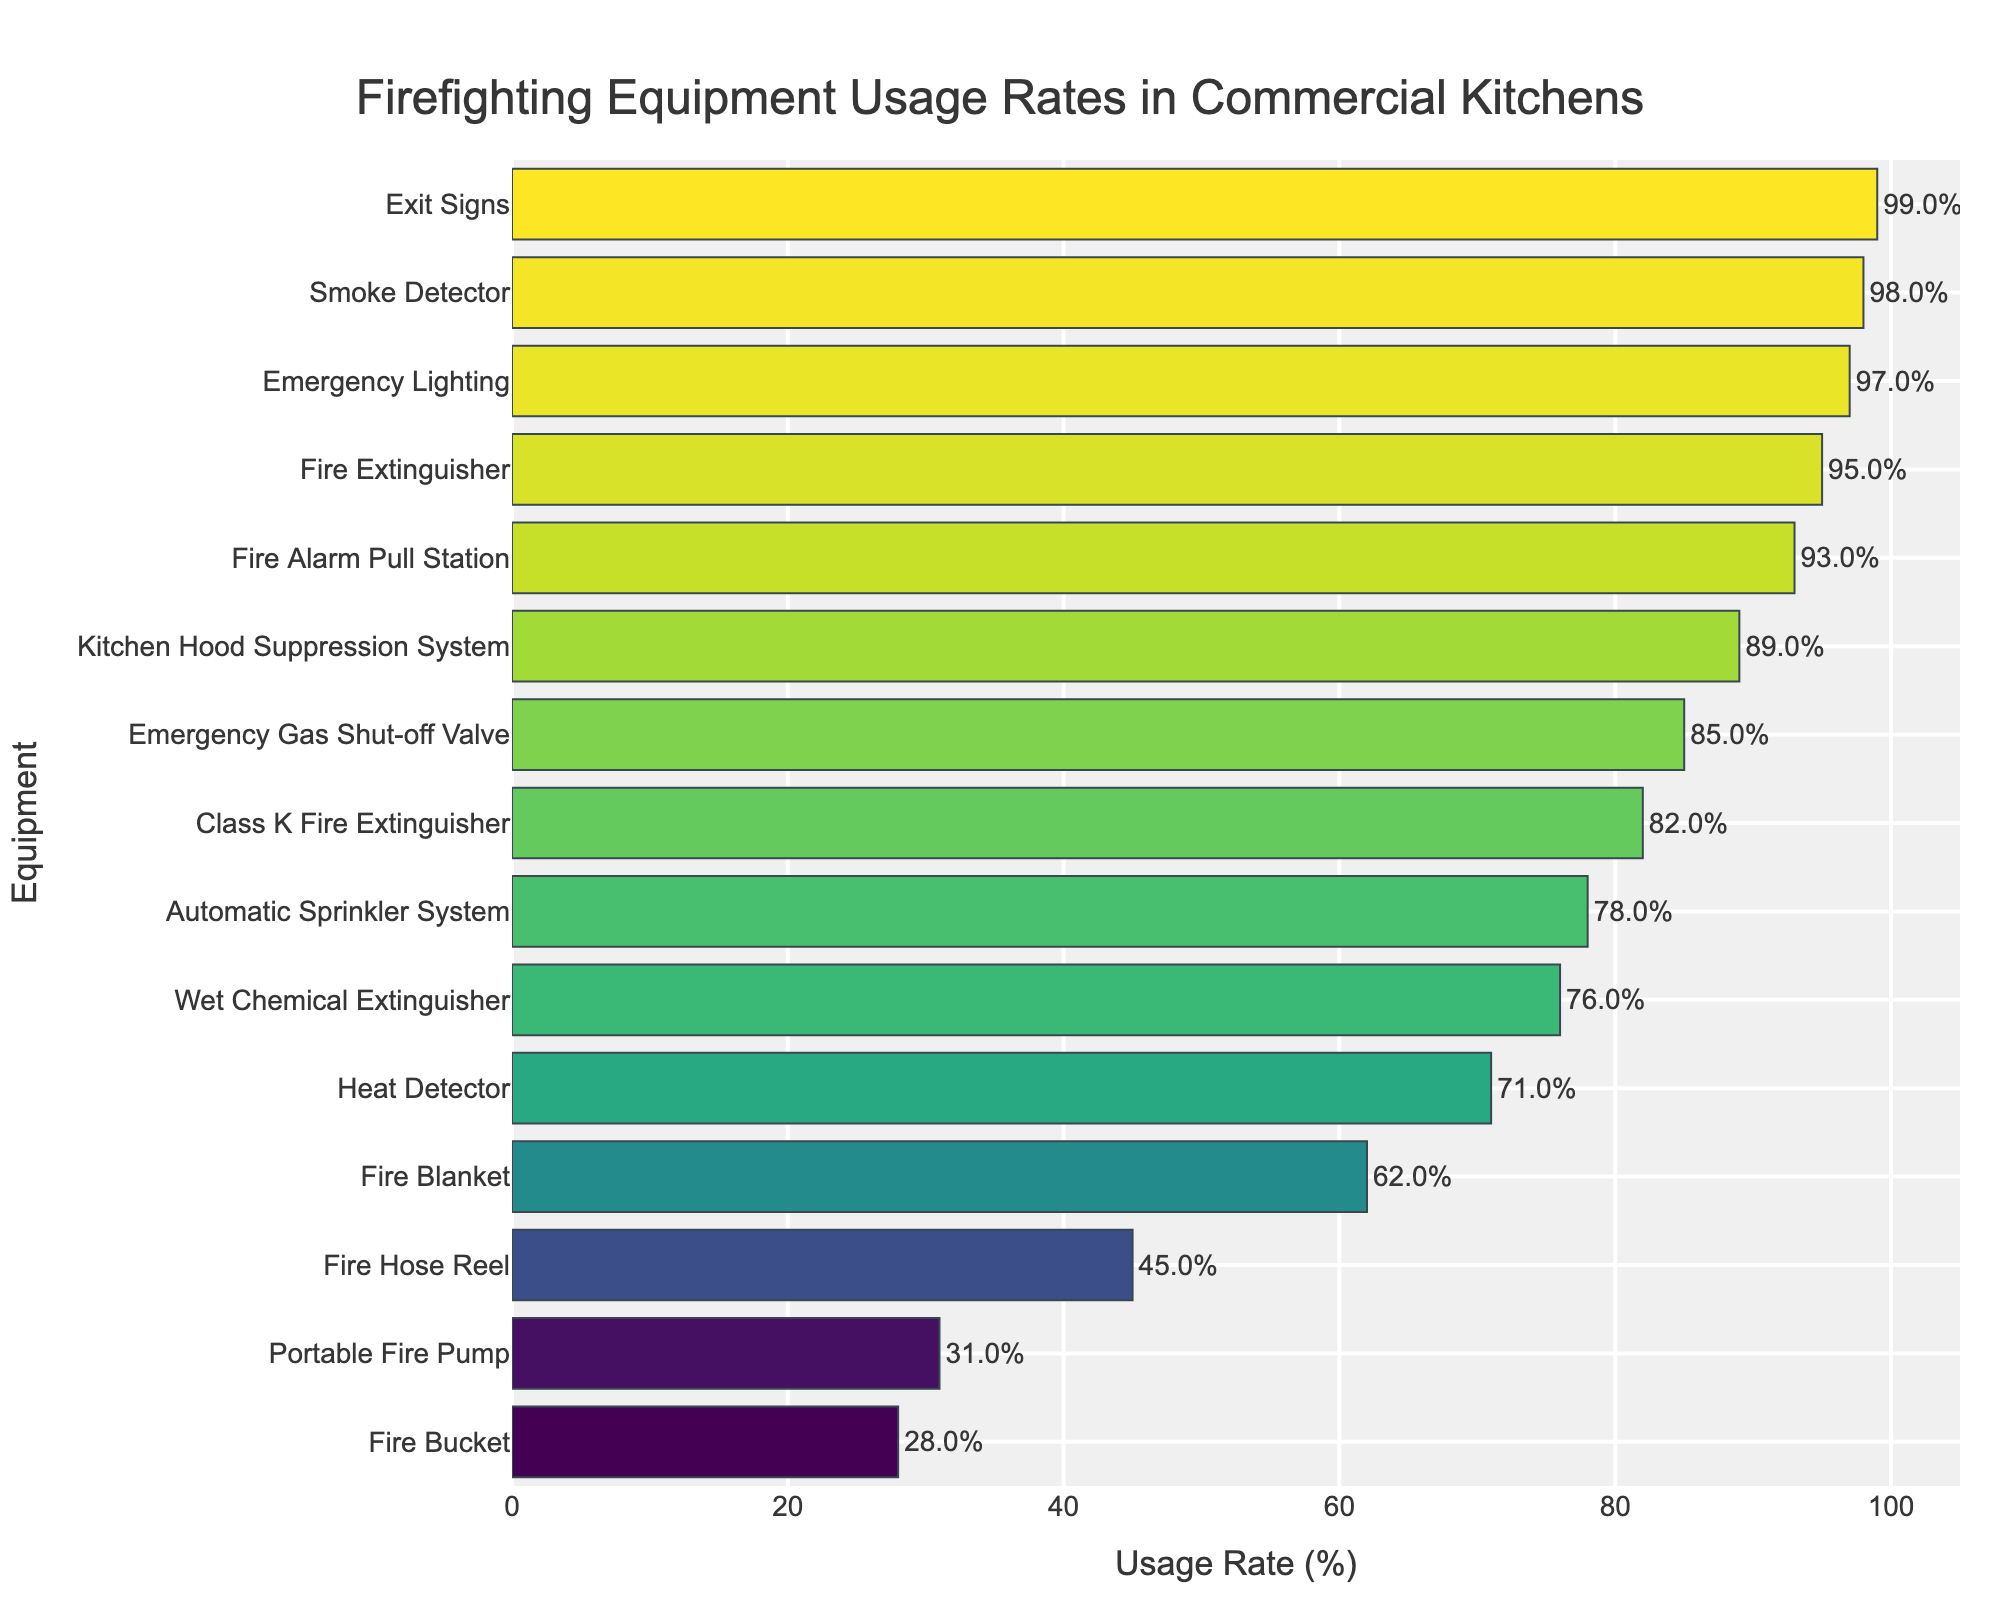Which piece of equipment has the highest usage rate? Among the bars representing the equipment usage rates, the highest bar corresponds to "Exit Signs" with a usage rate of 99%.
Answer: Exit Signs Which equipment has the lowest usage rate? The shortest bar in the chart corresponds to "Fire Bucket" with a usage rate of 28%.
Answer: Fire Bucket How much higher is the usage rate of Fire Extinguishers compared to Fire Buckets? The usage rate of "Fire Extinguisher" is 95%, and that of "Fire Bucket" is 28%. The difference is 95% - 28% = 67%.
Answer: 67% What is the average usage rate of Emergency Gas Shut-off Valve and Heat Detector? The usage rates are 85% for Emergency Gas Shut-off Valve and 71% for Heat Detector. The average is (85 + 71) / 2 = 78%.
Answer: 78% Which equipment has a usage rate that is approximately half of the Exit Signs? The usage rate for "Exit Signs" is 99%. Half of that rate is 49.5%. The closest equipment to this value is "Fire Hose Reel" with a usage rate of 45%.
Answer: Fire Hose Reel How many pieces of equipment have a usage rate above 80%? The bars with usage rates above 80% are for Fire Extinguisher, Automatic Sprinkler System, Kitchen Hood Suppression System, Smoke Detector, Emergency Gas Shut-off Valve, Fire Alarm Pull Station, Exit Signs, Emergency Lighting, and Class K Fire Extinguisher. There are 9 in total.
Answer: 9 What's the median usage rate of the equipment listed? First sort the usage rates: 28, 31, 45, 62, 71, 76, 78, 82, 85, 89, 93, 95, 97, 98, 99. Since there are 15 data points, the median is the 8th value, which is 82%.
Answer: 82% What is the total usage rate of the top three most-used equipment? The top three equipment by usage rate are Exit Signs (99%), Smoke Detector (98%), and Emergency Lighting (97%). The total is 99 + 98 + 97 = 294%.
Answer: 294% Which equipment has a usage rate closer to the Wet Chemical Extinguisher: Heat Detector or Automatic Sprinkler System? The usage rate of Wet Chemical Extinguisher is 76%. Heat Detector has 71% and Automatic Sprinkler System has 78%. The difference for Heat Detector (76 - 71) is 5%, and for Automatic Sprinkler System (78 - 76) is 2%, making Automatic Sprinkler System closer.
Answer: Automatic Sprinkler System Which two pieces of equipment have a combined usage rate that falls between 150% and 160%? Looking at pairs of usage rates, we find that the combination of Emergency Lighting (97%) and Fire Alarm Pull Station (93%) makes 97 + 93 = 190%, which is out of range. Then we check Automatic Sprinkler System (78%) and Fire Blanket (62%), resulting in 78 + 62 = 140%, still not in range. The suitable pair is Fire Hose Reel (45%) and Emergency Gas Shut-off Valve (85%) which results in 45 + 85 = 130%, outside the range. Testing Kitchen Hood Suppression System (89%) and Fire Blanket (62%) results in 89 + 62 = 151%, which is in the range.
Answer: Kitchen Hood Suppression System and Fire Blanket 